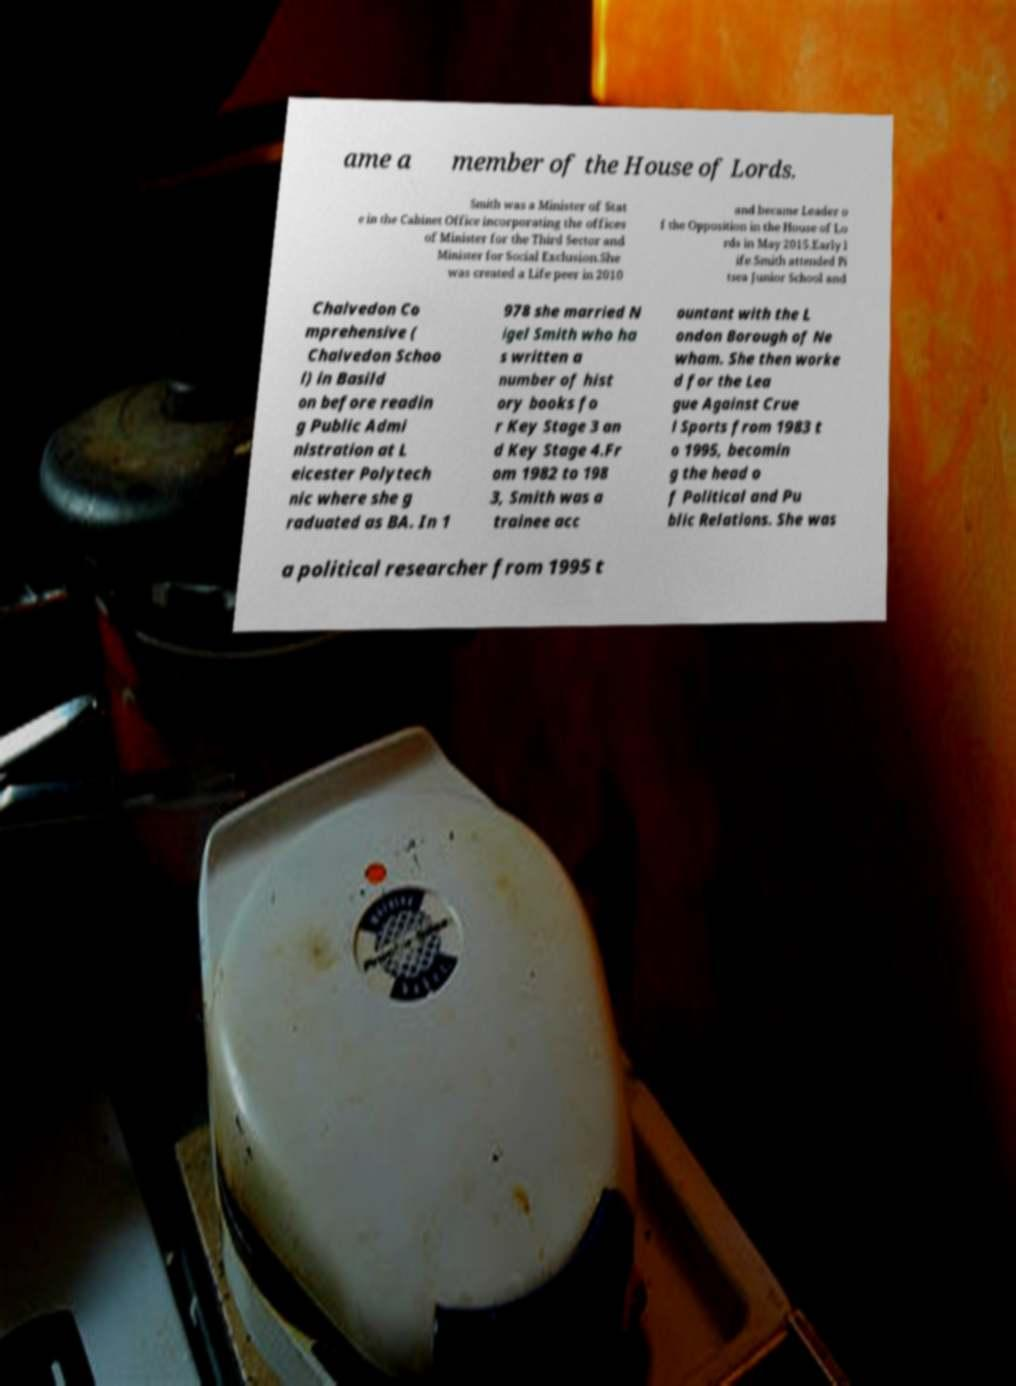Could you extract and type out the text from this image? ame a member of the House of Lords. Smith was a Minister of Stat e in the Cabinet Office incorporating the offices of Minister for the Third Sector and Minister for Social Exclusion.She was created a Life peer in 2010 and became Leader o f the Opposition in the House of Lo rds in May 2015.Early l ife.Smith attended Pi tsea Junior School and Chalvedon Co mprehensive ( Chalvedon Schoo l) in Basild on before readin g Public Admi nistration at L eicester Polytech nic where she g raduated as BA. In 1 978 she married N igel Smith who ha s written a number of hist ory books fo r Key Stage 3 an d Key Stage 4.Fr om 1982 to 198 3, Smith was a trainee acc ountant with the L ondon Borough of Ne wham. She then worke d for the Lea gue Against Crue l Sports from 1983 t o 1995, becomin g the head o f Political and Pu blic Relations. She was a political researcher from 1995 t 